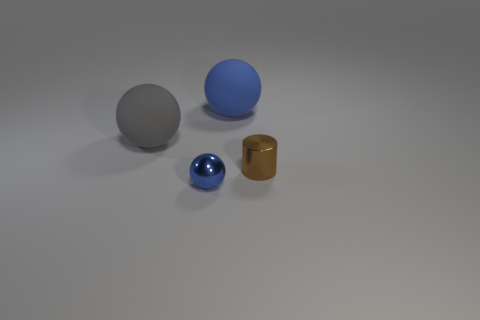How many gray things are the same material as the tiny cylinder?
Keep it short and to the point. 0. The thing that is the same color as the metal ball is what shape?
Ensure brevity in your answer.  Sphere. There is a small metallic object left of the blue matte thing; is it the same shape as the big blue thing?
Your answer should be very brief. Yes. What color is the other large object that is made of the same material as the big blue object?
Your answer should be compact. Gray. There is a thing left of the ball that is in front of the small brown cylinder; is there a thing that is to the left of it?
Offer a terse response. No. What is the shape of the blue matte thing?
Provide a short and direct response. Sphere. Is the number of gray rubber objects to the left of the gray matte sphere less than the number of large purple metallic cubes?
Offer a terse response. No. Is there a small object that has the same shape as the big gray rubber thing?
Offer a terse response. Yes. There is a thing that is the same size as the cylinder; what is its shape?
Your response must be concise. Sphere. How many objects are either brown balls or shiny things?
Offer a terse response. 2. 